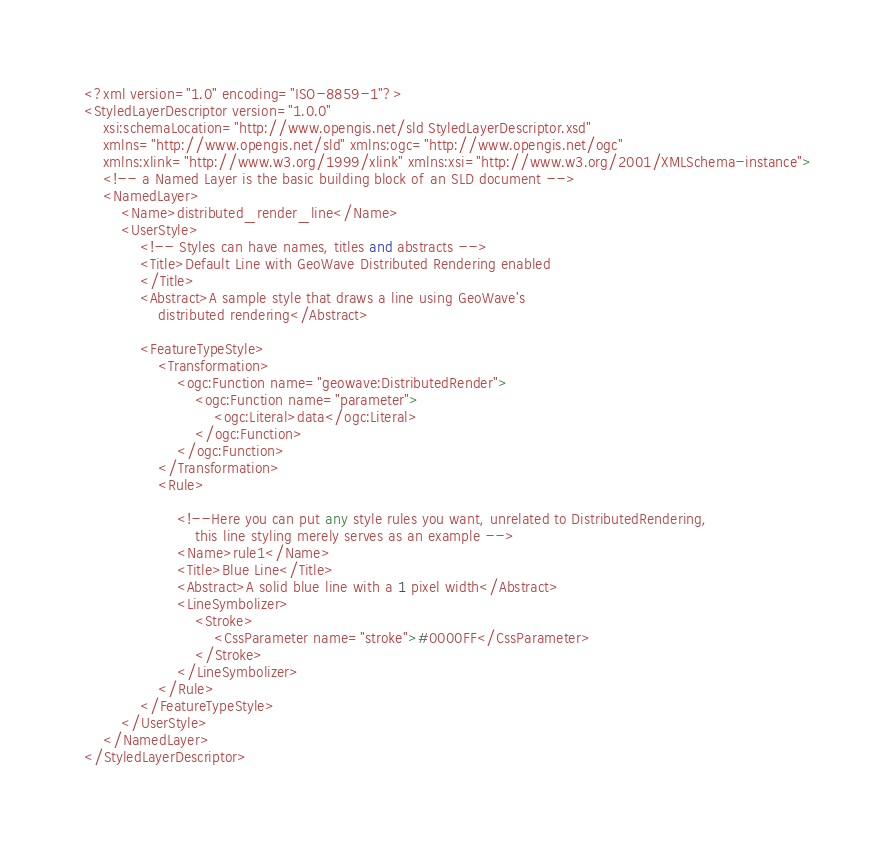<code> <loc_0><loc_0><loc_500><loc_500><_Scheme_><?xml version="1.0" encoding="ISO-8859-1"?>
<StyledLayerDescriptor version="1.0.0"
	xsi:schemaLocation="http://www.opengis.net/sld StyledLayerDescriptor.xsd"
	xmlns="http://www.opengis.net/sld" xmlns:ogc="http://www.opengis.net/ogc"
	xmlns:xlink="http://www.w3.org/1999/xlink" xmlns:xsi="http://www.w3.org/2001/XMLSchema-instance">
	<!-- a Named Layer is the basic building block of an SLD document -->
	<NamedLayer>
		<Name>distributed_render_line</Name>
		<UserStyle>
			<!-- Styles can have names, titles and abstracts -->
			<Title>Default Line with GeoWave Distributed Rendering enabled
			</Title>
			<Abstract>A sample style that draws a line using GeoWave's
				distributed rendering</Abstract>

			<FeatureTypeStyle>
				<Transformation>
					<ogc:Function name="geowave:DistributedRender">
						<ogc:Function name="parameter">
							<ogc:Literal>data</ogc:Literal>
						</ogc:Function>
					</ogc:Function>
				</Transformation>
				<Rule>

					<!--Here you can put any style rules you want, unrelated to DistributedRendering, 
						this line styling merely serves as an example -->
					<Name>rule1</Name>
					<Title>Blue Line</Title>
					<Abstract>A solid blue line with a 1 pixel width</Abstract>
					<LineSymbolizer>
						<Stroke>
							<CssParameter name="stroke">#0000FF</CssParameter>
						</Stroke>
					</LineSymbolizer>
				</Rule>
			</FeatureTypeStyle>
		</UserStyle>
	</NamedLayer>
</StyledLayerDescriptor></code> 